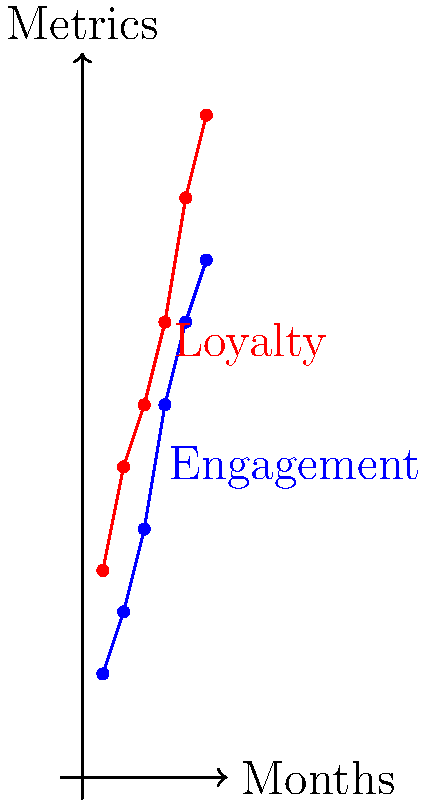As a beauty brand owner, you've been tracking social media engagement and customer loyalty metrics over the past 6 months. The graph shows the trends for both metrics. If the correlation coefficient between engagement and loyalty is 0.95, what can you conclude about the relationship between these two metrics, and how might this inform your strategy for improving customer engagement and brand loyalty? To interpret this graph and answer the question, let's follow these steps:

1. Understand the graph:
   - The x-axis represents months (1-6)
   - The y-axis represents the metrics (engagement in blue, loyalty in red)
   - Both metrics show an upward trend over time

2. Analyze the correlation coefficient:
   - The given correlation coefficient is 0.95
   - Correlation coefficients range from -1 to 1
   - A value of 0.95 indicates a very strong positive correlation

3. Interpret the relationship:
   - The strong positive correlation (0.95) suggests that as engagement increases, loyalty tends to increase as well
   - This relationship is also visually apparent in the graph, as both lines show similar upward trends

4. Consider the implications:
   - The strong correlation doesn't necessarily imply causation, but it suggests a close relationship between engagement and loyalty
   - Improving engagement might lead to increased loyalty, or vice versa
   - There may be external factors influencing both metrics simultaneously

5. Develop a strategy:
   - Focus on increasing social media engagement, as it's likely to positively impact customer loyalty
   - Implement tactics to boost both engagement and loyalty simultaneously
   - Monitor these metrics closely to see if the relationship holds over time

6. Potential actions:
   - Create more interactive content on social media to boost engagement
   - Develop a loyalty program that encourages social media interaction
   - Use social media to showcase loyal customers and their experiences with your brand

In conclusion, the strong positive correlation between engagement and loyalty suggests that these metrics are closely related. This information can be used to develop a strategy that focuses on improving both aspects simultaneously, potentially leading to overall growth in customer engagement and brand loyalty.
Answer: Strong positive correlation between engagement and loyalty; focus on improving both simultaneously to enhance overall brand performance. 